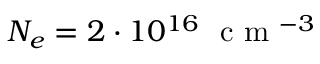Convert formula to latex. <formula><loc_0><loc_0><loc_500><loc_500>N _ { e } = 2 \cdot 1 0 ^ { 1 6 } c m ^ { - 3 }</formula> 